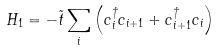<formula> <loc_0><loc_0><loc_500><loc_500>H _ { 1 } = - \tilde { t } \sum _ { i } \left ( c _ { i } ^ { \dagger } c _ { i + 1 } + c _ { i + 1 } ^ { \dagger } c _ { i } \right )</formula> 